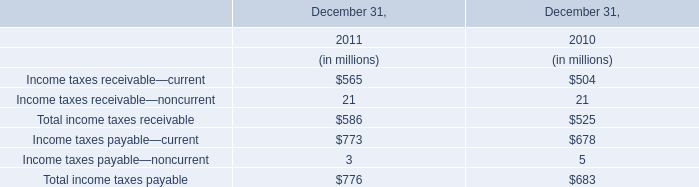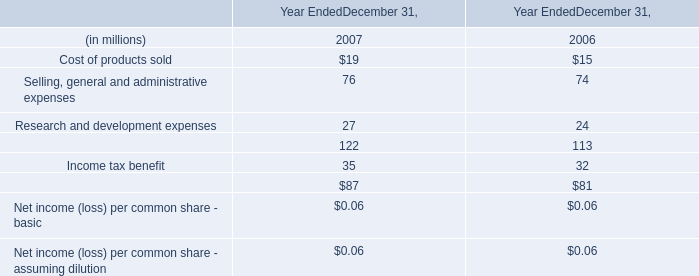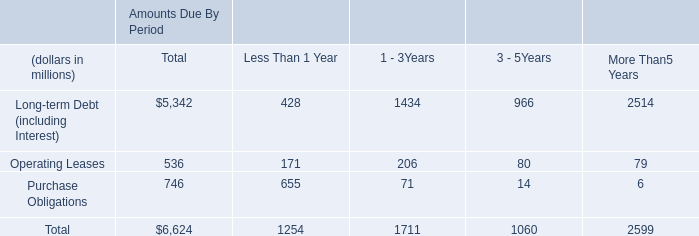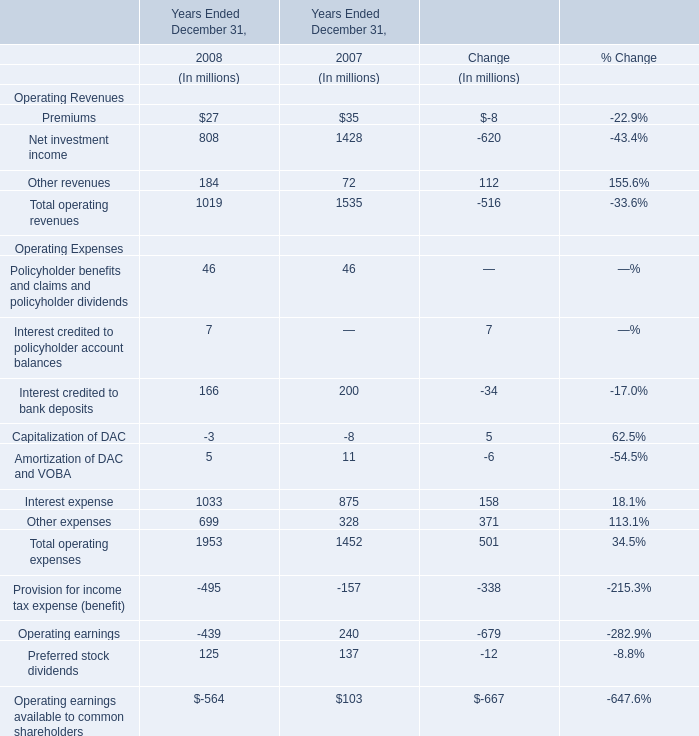What is the growth rate of Total operating revenues between 2007 Ended December 31 and 2008 Ended December 31? 
Computations: ((1019 - 1535) / 1535)
Answer: -0.33616. 